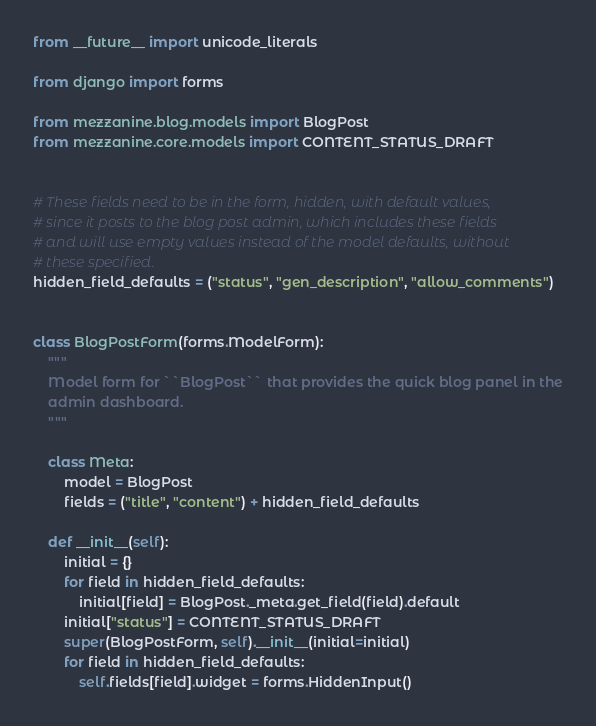Convert code to text. <code><loc_0><loc_0><loc_500><loc_500><_Python_>from __future__ import unicode_literals

from django import forms

from mezzanine.blog.models import BlogPost
from mezzanine.core.models import CONTENT_STATUS_DRAFT


# These fields need to be in the form, hidden, with default values,
# since it posts to the blog post admin, which includes these fields
# and will use empty values instead of the model defaults, without
# these specified.
hidden_field_defaults = ("status", "gen_description", "allow_comments")


class BlogPostForm(forms.ModelForm):
    """
    Model form for ``BlogPost`` that provides the quick blog panel in the
    admin dashboard.
    """

    class Meta:
        model = BlogPost
        fields = ("title", "content") + hidden_field_defaults

    def __init__(self):
        initial = {}
        for field in hidden_field_defaults:
            initial[field] = BlogPost._meta.get_field(field).default
        initial["status"] = CONTENT_STATUS_DRAFT
        super(BlogPostForm, self).__init__(initial=initial)
        for field in hidden_field_defaults:
            self.fields[field].widget = forms.HiddenInput()
</code> 